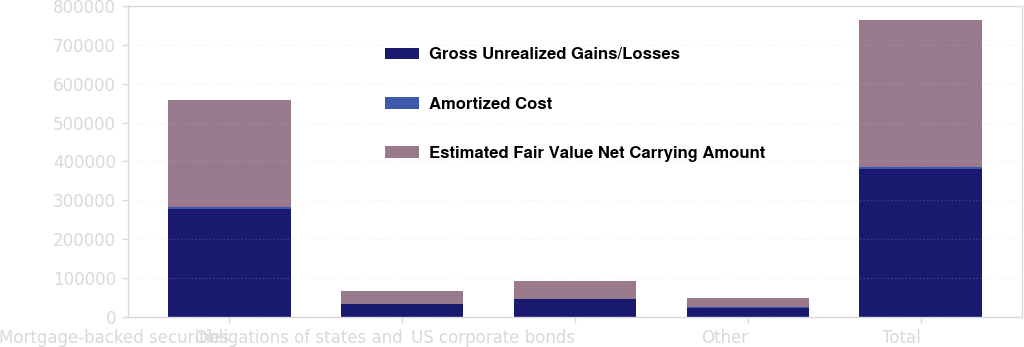Convert chart to OTSL. <chart><loc_0><loc_0><loc_500><loc_500><stacked_bar_chart><ecel><fcel>Mortgage-backed securities<fcel>Obligations of states and<fcel>US corporate bonds<fcel>Other<fcel>Total<nl><fcel>Gross Unrealized Gains/Losses<fcel>278932<fcel>33425<fcel>45718<fcel>23450<fcel>381525<nl><fcel>Amortized Cost<fcel>4611<fcel>456<fcel>731<fcel>996<fcel>4802<nl><fcel>Estimated Fair Value Net Carrying Amount<fcel>274321<fcel>32969<fcel>44987<fcel>24446<fcel>376723<nl></chart> 